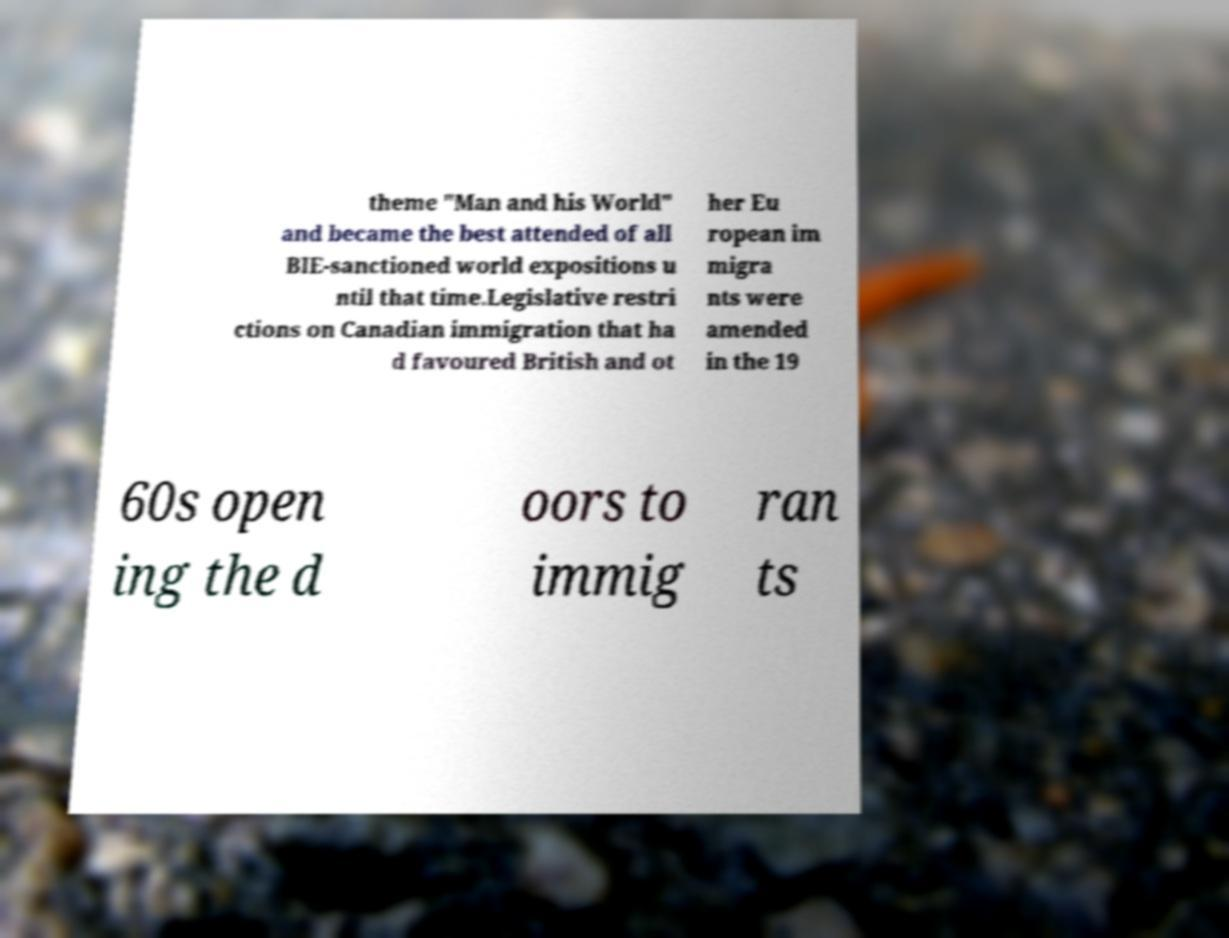Please read and relay the text visible in this image. What does it say? theme "Man and his World" and became the best attended of all BIE-sanctioned world expositions u ntil that time.Legislative restri ctions on Canadian immigration that ha d favoured British and ot her Eu ropean im migra nts were amended in the 19 60s open ing the d oors to immig ran ts 